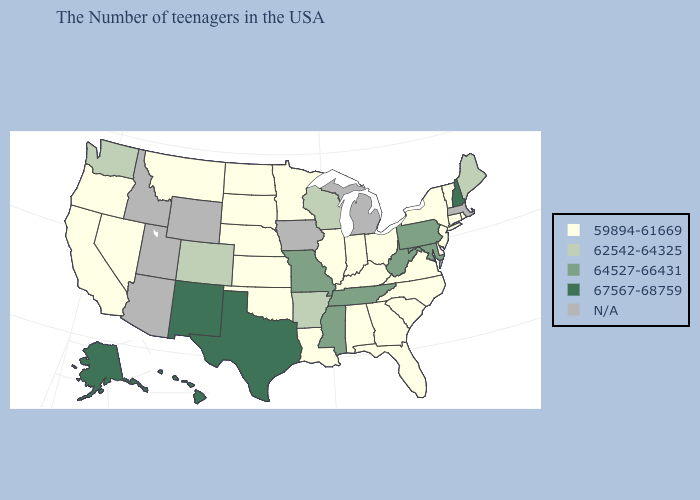What is the lowest value in the USA?
Keep it brief. 59894-61669. How many symbols are there in the legend?
Be succinct. 5. What is the lowest value in the USA?
Keep it brief. 59894-61669. What is the value of Louisiana?
Keep it brief. 59894-61669. Does Pennsylvania have the lowest value in the USA?
Short answer required. No. How many symbols are there in the legend?
Answer briefly. 5. What is the lowest value in the South?
Keep it brief. 59894-61669. Name the states that have a value in the range 67567-68759?
Be succinct. New Hampshire, Texas, New Mexico, Alaska, Hawaii. Name the states that have a value in the range 64527-66431?
Keep it brief. Maryland, Pennsylvania, West Virginia, Tennessee, Mississippi, Missouri. What is the highest value in states that border Utah?
Quick response, please. 67567-68759. What is the value of Hawaii?
Concise answer only. 67567-68759. Name the states that have a value in the range N/A?
Answer briefly. Massachusetts, Michigan, Iowa, Wyoming, Utah, Arizona, Idaho. What is the value of New Mexico?
Be succinct. 67567-68759. 